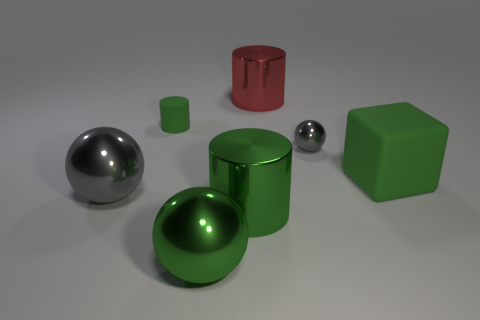Are there any other things that are the same shape as the large rubber object?
Offer a very short reply. No. What is the material of the small cylinder that is the same color as the block?
Your response must be concise. Rubber. Are there the same number of blocks that are behind the big red shiny object and tiny gray objects?
Your answer should be very brief. No. Are there any red shiny cylinders in front of the small gray metal object?
Provide a short and direct response. No. Does the tiny green object have the same shape as the big green thing behind the green shiny cylinder?
Ensure brevity in your answer.  No. What is the color of the other thing that is made of the same material as the tiny green thing?
Your response must be concise. Green. The big rubber object is what color?
Keep it short and to the point. Green. Are the big gray object and the large green object behind the big gray thing made of the same material?
Your answer should be compact. No. What number of big cylinders are both in front of the green block and behind the small metal object?
Keep it short and to the point. 0. The gray object that is the same size as the rubber cube is what shape?
Offer a terse response. Sphere. 